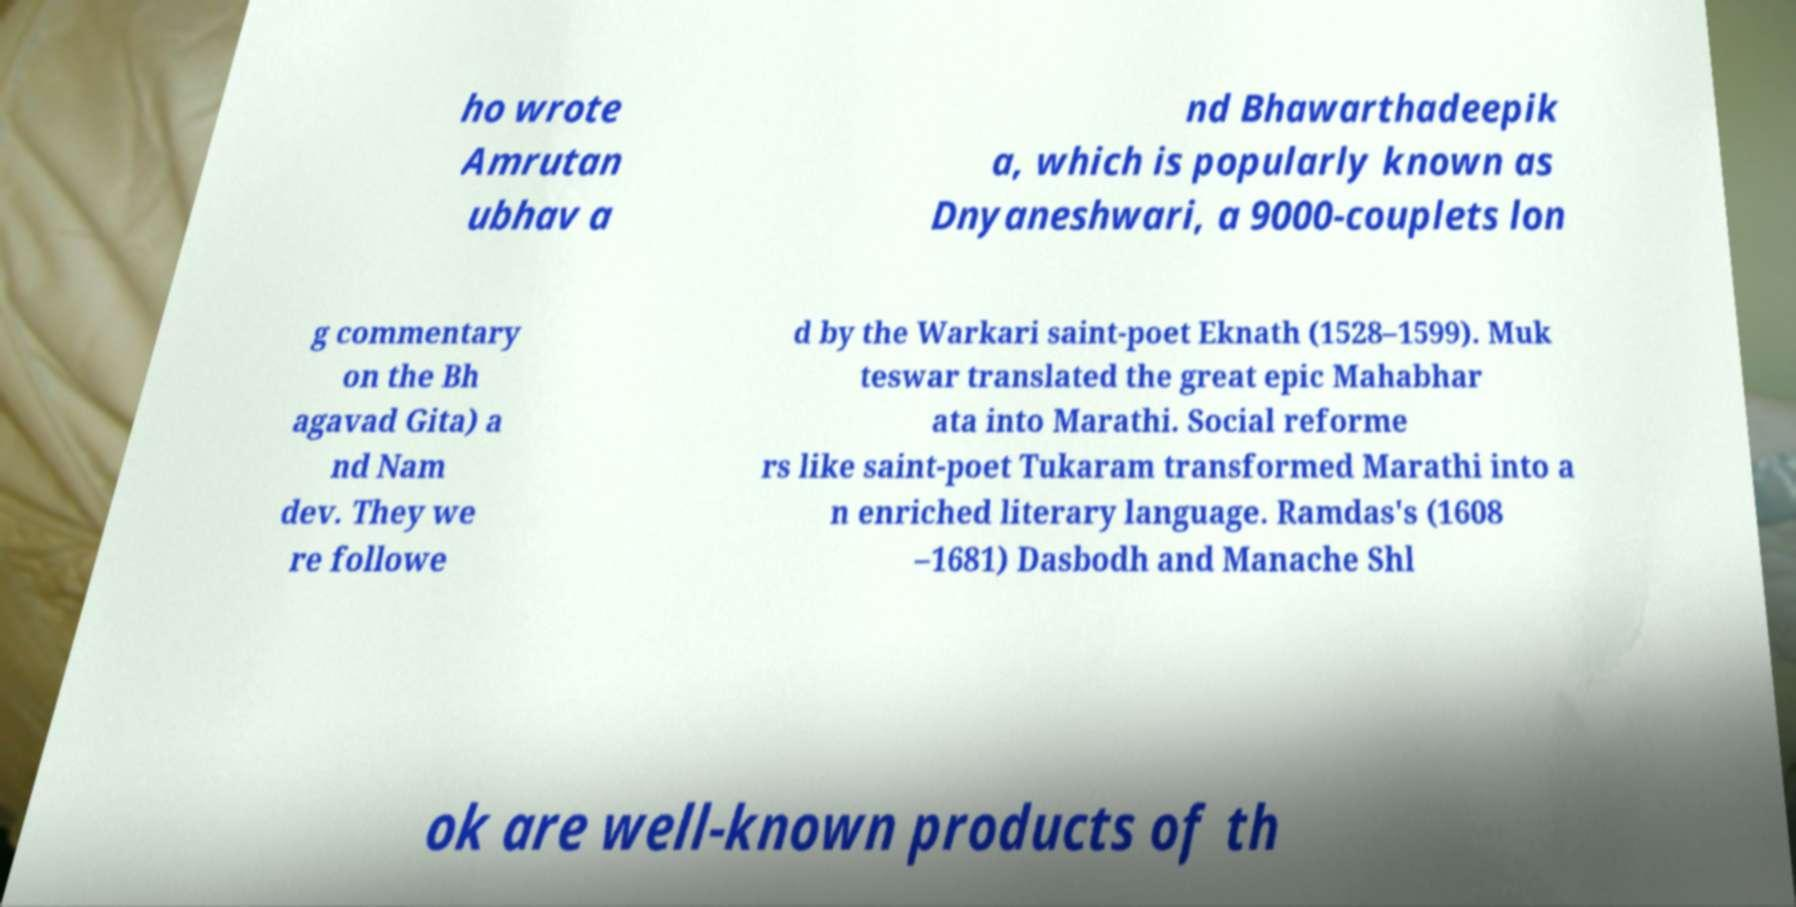Please read and relay the text visible in this image. What does it say? ho wrote Amrutan ubhav a nd Bhawarthadeepik a, which is popularly known as Dnyaneshwari, a 9000-couplets lon g commentary on the Bh agavad Gita) a nd Nam dev. They we re followe d by the Warkari saint-poet Eknath (1528–1599). Muk teswar translated the great epic Mahabhar ata into Marathi. Social reforme rs like saint-poet Tukaram transformed Marathi into a n enriched literary language. Ramdas's (1608 –1681) Dasbodh and Manache Shl ok are well-known products of th 